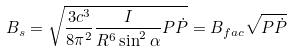Convert formula to latex. <formula><loc_0><loc_0><loc_500><loc_500>B _ { s } = \sqrt { \frac { 3 c ^ { 3 } } { 8 \pi ^ { 2 } } \frac { I } { R ^ { 6 } \sin ^ { 2 } \alpha } P \dot { P } } = B _ { f a c } \sqrt { P \dot { P } }</formula> 